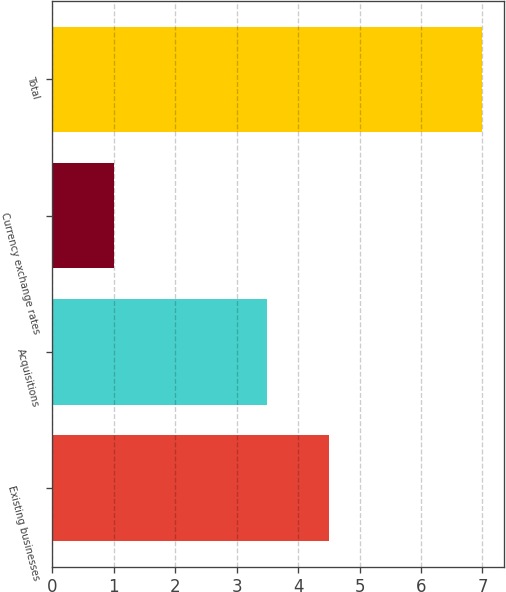Convert chart. <chart><loc_0><loc_0><loc_500><loc_500><bar_chart><fcel>Existing businesses<fcel>Acquisitions<fcel>Currency exchange rates<fcel>Total<nl><fcel>4.5<fcel>3.5<fcel>1<fcel>7<nl></chart> 